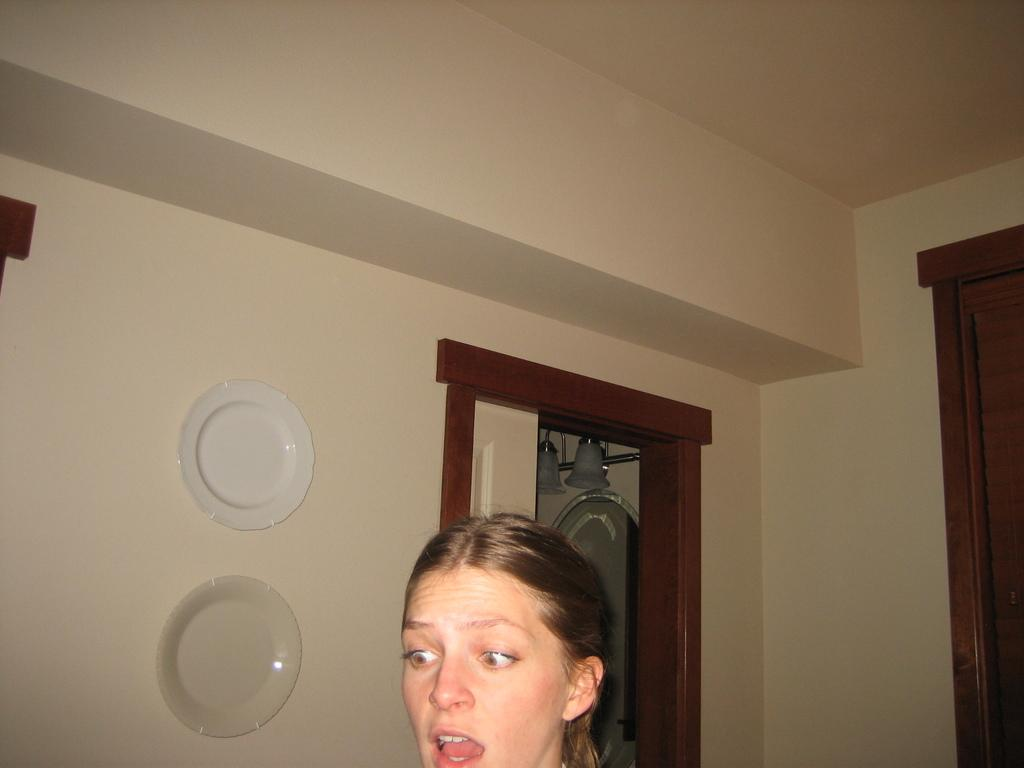What is the main subject of the image? There is a woman's face in the image. What can be seen behind the woman? There is a wall behind the woman. Are there any architectural features visible in the image? Yes, there are doors present in the image. What is attached to the wall in the image? Plates are attached to the wall. What type of meal is being prepared on the plates in the image? There are no plates with food visible in the image; only plates attached to the wall are present. Can you tell me how much ink is used to draw the woman's face in the image? There is no indication that the woman's face is a drawing or that ink was used to create it. 